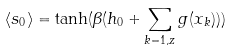Convert formula to latex. <formula><loc_0><loc_0><loc_500><loc_500>\langle s _ { 0 } \rangle = \tanh ( \beta ( h _ { 0 } + \sum _ { k = 1 , z } g ( x _ { k } ) ) )</formula> 